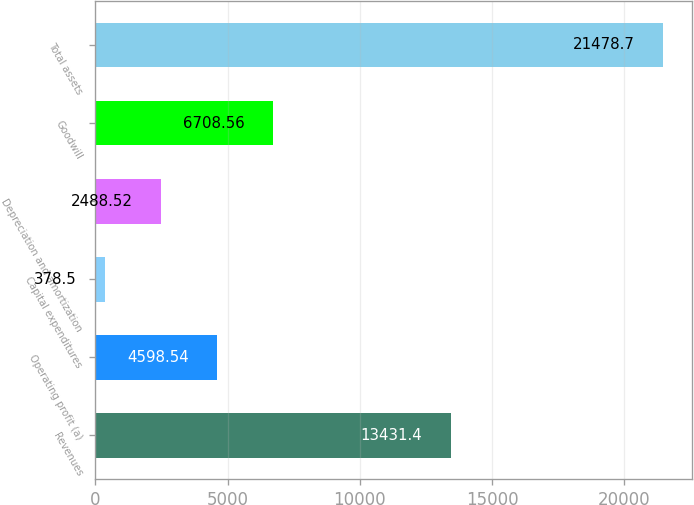<chart> <loc_0><loc_0><loc_500><loc_500><bar_chart><fcel>Revenues<fcel>Operating profit (a)<fcel>Capital expenditures<fcel>Depreciation and amortization<fcel>Goodwill<fcel>Total assets<nl><fcel>13431.4<fcel>4598.54<fcel>378.5<fcel>2488.52<fcel>6708.56<fcel>21478.7<nl></chart> 